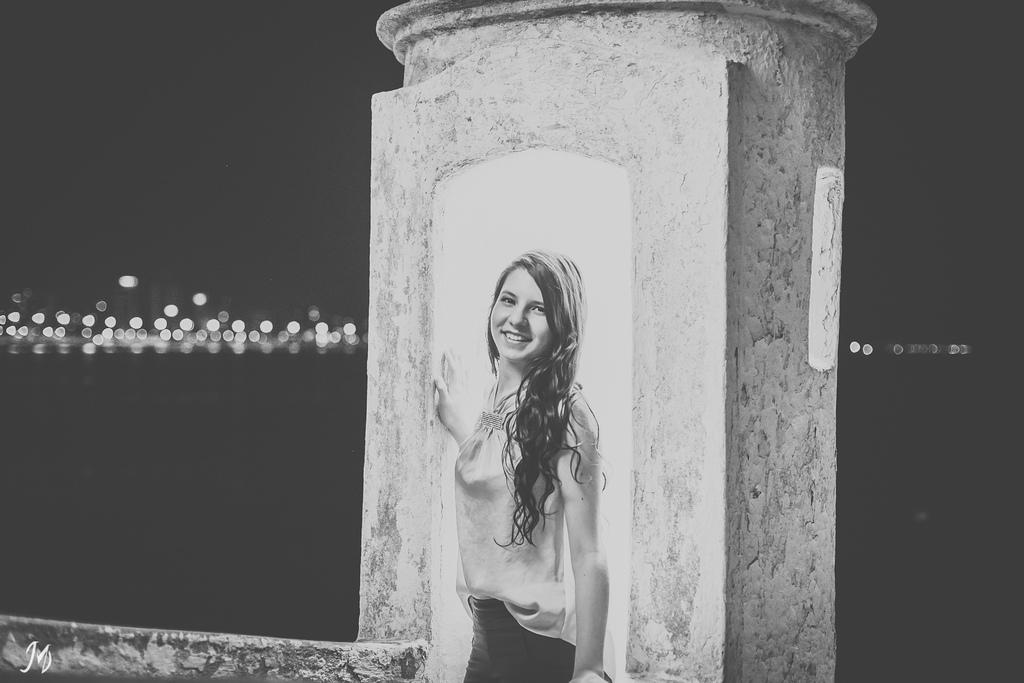Who is the main subject in the image? There is a girl in the center of the image. What can be seen in the background of the image? There are lights in the background area of the image. What type of ink is the girl using to write in the image? There is no ink or writing present in the image; it features a girl and lights in the background. 